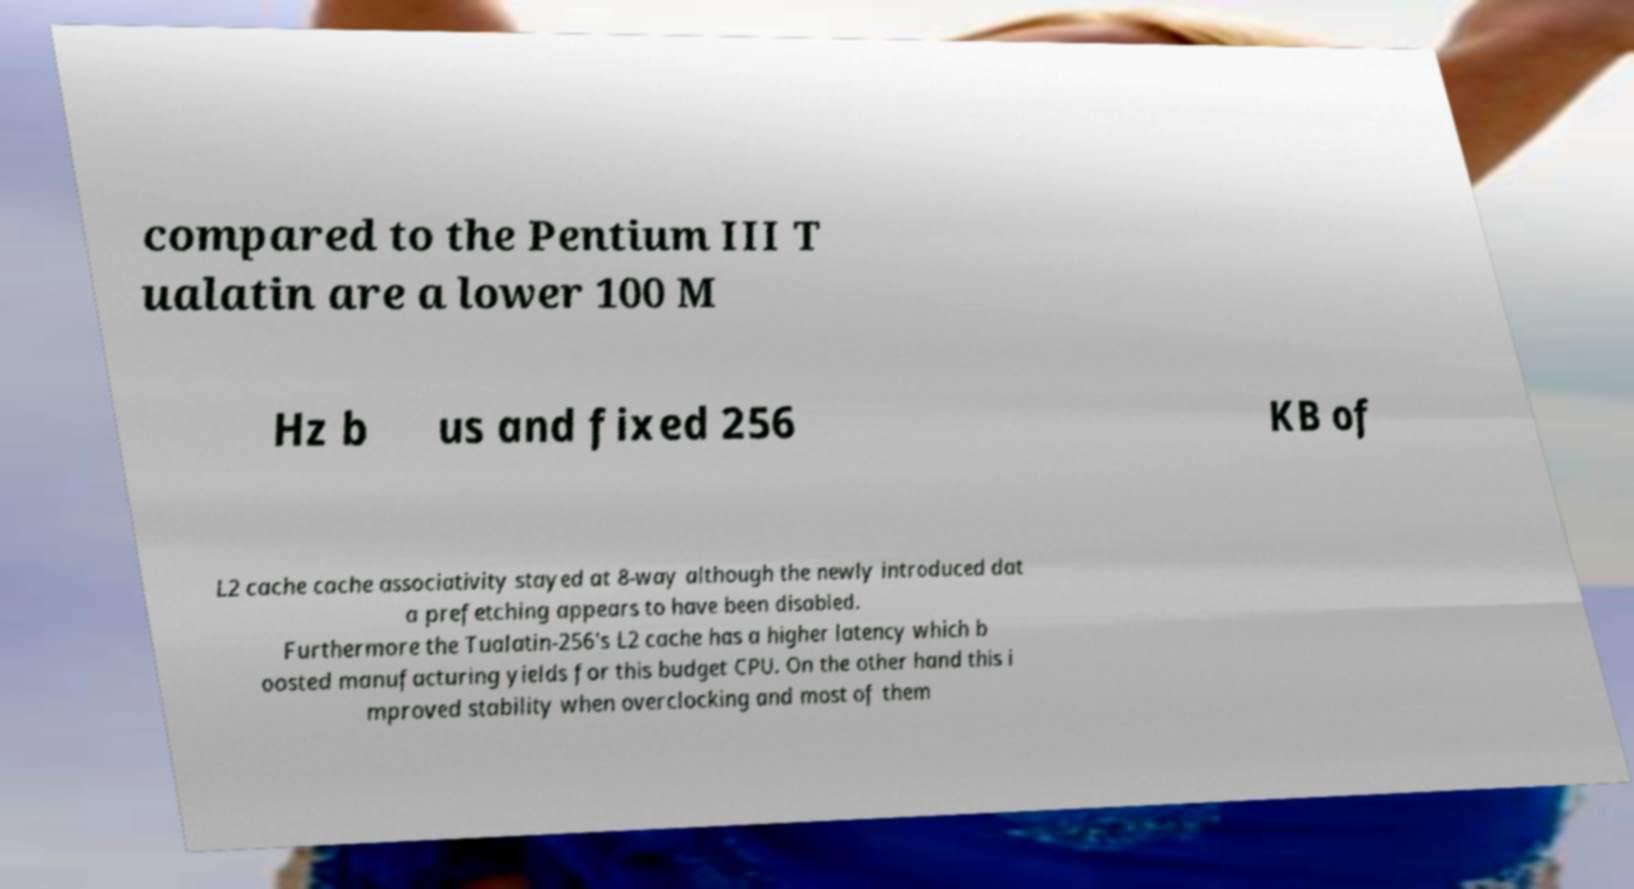What messages or text are displayed in this image? I need them in a readable, typed format. compared to the Pentium III T ualatin are a lower 100 M Hz b us and fixed 256 KB of L2 cache cache associativity stayed at 8-way although the newly introduced dat a prefetching appears to have been disabled. Furthermore the Tualatin-256's L2 cache has a higher latency which b oosted manufacturing yields for this budget CPU. On the other hand this i mproved stability when overclocking and most of them 